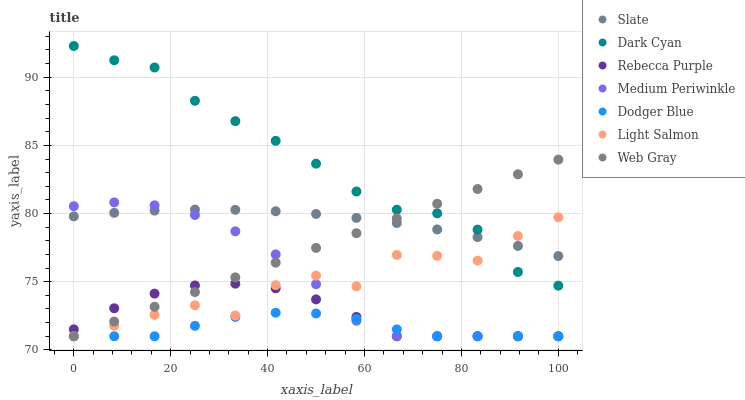Does Dodger Blue have the minimum area under the curve?
Answer yes or no. Yes. Does Dark Cyan have the maximum area under the curve?
Answer yes or no. Yes. Does Web Gray have the minimum area under the curve?
Answer yes or no. No. Does Web Gray have the maximum area under the curve?
Answer yes or no. No. Is Web Gray the smoothest?
Answer yes or no. Yes. Is Light Salmon the roughest?
Answer yes or no. Yes. Is Slate the smoothest?
Answer yes or no. No. Is Slate the roughest?
Answer yes or no. No. Does Light Salmon have the lowest value?
Answer yes or no. Yes. Does Slate have the lowest value?
Answer yes or no. No. Does Dark Cyan have the highest value?
Answer yes or no. Yes. Does Web Gray have the highest value?
Answer yes or no. No. Is Dodger Blue less than Slate?
Answer yes or no. Yes. Is Dark Cyan greater than Medium Periwinkle?
Answer yes or no. Yes. Does Web Gray intersect Rebecca Purple?
Answer yes or no. Yes. Is Web Gray less than Rebecca Purple?
Answer yes or no. No. Is Web Gray greater than Rebecca Purple?
Answer yes or no. No. Does Dodger Blue intersect Slate?
Answer yes or no. No. 